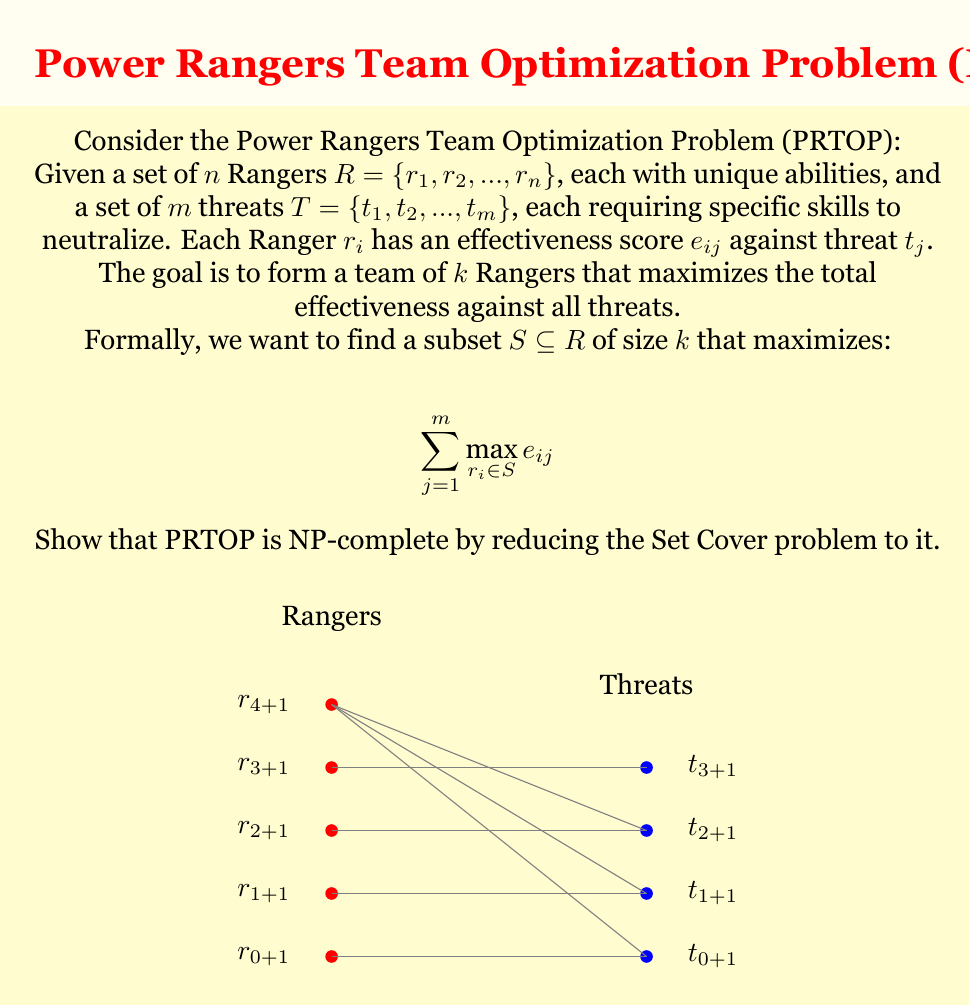Solve this math problem. To prove that PRTOP is NP-complete, we need to show that it's in NP and that it's NP-hard. Let's approach this step-by-step:

1. PRTOP is in NP:
   We can verify a solution in polynomial time by calculating the total effectiveness of a given team against all threats.

2. PRTOP is NP-hard:
   We'll reduce the Set Cover problem (known to be NP-complete) to PRTOP.

Set Cover Problem:
Given a universe $U = \{u_1, u_2, ..., u_m\}$, a collection of subsets $S = \{S_1, S_2, ..., S_n\}$ of $U$, and an integer $l$, find if there exist $l$ or fewer subsets in $S$ whose union is $U$.

Reduction:
a) For each element $u_i \in U$, create a threat $t_i$ in PRTOP.
b) For each subset $S_j \in S$, create a Ranger $r_j$ in PRTOP.
c) Set $e_{ij} = 1$ if $u_i \in S_j$, and $e_{ij} = 0$ otherwise.
d) Set $k = l$ (the number of Rangers to select equals the number of subsets in Set Cover).

Now, solving PRTOP with a target effectiveness of $m$ (the number of threats) is equivalent to solving the Set Cover problem:
- If PRTOP has a solution with total effectiveness $m$, it means we found $k$ Rangers that cover all threats, which corresponds to $l$ subsets that cover all elements in Set Cover.
- If Set Cover has a solution, the corresponding Rangers in PRTOP will achieve the maximum effectiveness of $m$.

This reduction is polynomial-time, as we create one threat for each element and one Ranger for each subset.

3. Optimization vs. Decision:
   The optimization version of PRTOP (maximizing effectiveness) is at least as hard as the decision version (achieving a target effectiveness). If we can solve the optimization version, we can solve the decision version.

Therefore, PRTOP is NP-complete, and its optimization version is NP-hard.
Answer: NP-complete 